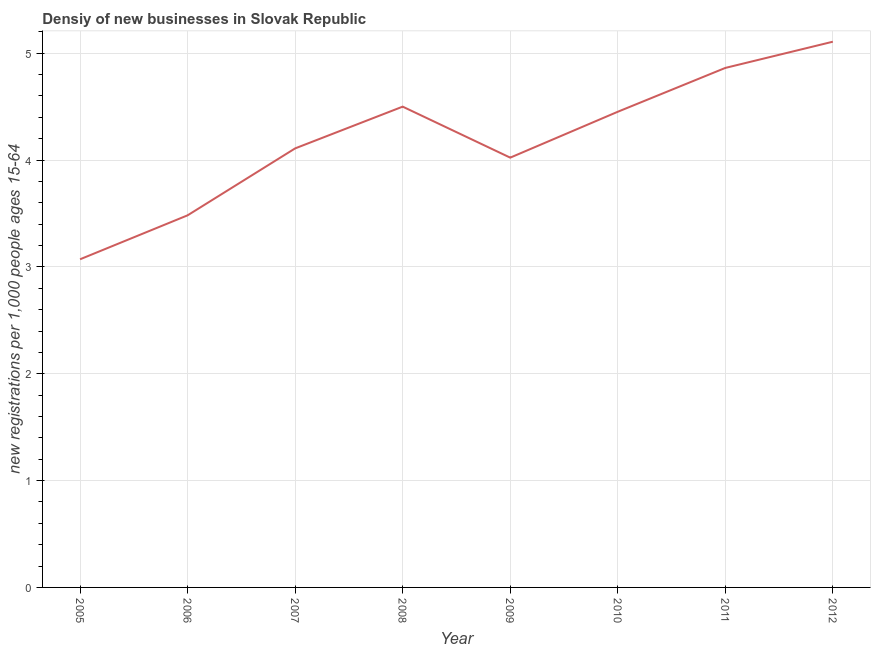What is the density of new business in 2007?
Your response must be concise. 4.11. Across all years, what is the maximum density of new business?
Provide a short and direct response. 5.11. Across all years, what is the minimum density of new business?
Provide a short and direct response. 3.07. In which year was the density of new business maximum?
Make the answer very short. 2012. What is the sum of the density of new business?
Offer a terse response. 33.61. What is the difference between the density of new business in 2009 and 2011?
Provide a short and direct response. -0.84. What is the average density of new business per year?
Make the answer very short. 4.2. What is the median density of new business?
Provide a succinct answer. 4.28. In how many years, is the density of new business greater than 1.8 ?
Offer a very short reply. 8. Do a majority of the years between 2009 and 2008 (inclusive) have density of new business greater than 4.8 ?
Provide a short and direct response. No. What is the ratio of the density of new business in 2005 to that in 2012?
Your response must be concise. 0.6. Is the density of new business in 2008 less than that in 2009?
Offer a terse response. No. Is the difference between the density of new business in 2009 and 2011 greater than the difference between any two years?
Your answer should be compact. No. What is the difference between the highest and the second highest density of new business?
Offer a very short reply. 0.25. Is the sum of the density of new business in 2010 and 2011 greater than the maximum density of new business across all years?
Make the answer very short. Yes. What is the difference between the highest and the lowest density of new business?
Ensure brevity in your answer.  2.04. Does the density of new business monotonically increase over the years?
Your answer should be compact. No. How many years are there in the graph?
Offer a very short reply. 8. What is the difference between two consecutive major ticks on the Y-axis?
Ensure brevity in your answer.  1. Are the values on the major ticks of Y-axis written in scientific E-notation?
Your answer should be very brief. No. What is the title of the graph?
Your answer should be compact. Densiy of new businesses in Slovak Republic. What is the label or title of the X-axis?
Give a very brief answer. Year. What is the label or title of the Y-axis?
Give a very brief answer. New registrations per 1,0 people ages 15-64. What is the new registrations per 1,000 people ages 15-64 of 2005?
Your response must be concise. 3.07. What is the new registrations per 1,000 people ages 15-64 in 2006?
Your answer should be very brief. 3.48. What is the new registrations per 1,000 people ages 15-64 of 2007?
Your answer should be very brief. 4.11. What is the new registrations per 1,000 people ages 15-64 in 2008?
Provide a short and direct response. 4.5. What is the new registrations per 1,000 people ages 15-64 of 2009?
Keep it short and to the point. 4.02. What is the new registrations per 1,000 people ages 15-64 of 2010?
Keep it short and to the point. 4.45. What is the new registrations per 1,000 people ages 15-64 in 2011?
Your answer should be compact. 4.86. What is the new registrations per 1,000 people ages 15-64 in 2012?
Your response must be concise. 5.11. What is the difference between the new registrations per 1,000 people ages 15-64 in 2005 and 2006?
Keep it short and to the point. -0.41. What is the difference between the new registrations per 1,000 people ages 15-64 in 2005 and 2007?
Offer a terse response. -1.04. What is the difference between the new registrations per 1,000 people ages 15-64 in 2005 and 2008?
Your response must be concise. -1.43. What is the difference between the new registrations per 1,000 people ages 15-64 in 2005 and 2009?
Provide a short and direct response. -0.95. What is the difference between the new registrations per 1,000 people ages 15-64 in 2005 and 2010?
Give a very brief answer. -1.38. What is the difference between the new registrations per 1,000 people ages 15-64 in 2005 and 2011?
Your answer should be compact. -1.79. What is the difference between the new registrations per 1,000 people ages 15-64 in 2005 and 2012?
Provide a short and direct response. -2.04. What is the difference between the new registrations per 1,000 people ages 15-64 in 2006 and 2007?
Offer a very short reply. -0.63. What is the difference between the new registrations per 1,000 people ages 15-64 in 2006 and 2008?
Provide a succinct answer. -1.02. What is the difference between the new registrations per 1,000 people ages 15-64 in 2006 and 2009?
Make the answer very short. -0.54. What is the difference between the new registrations per 1,000 people ages 15-64 in 2006 and 2010?
Provide a succinct answer. -0.97. What is the difference between the new registrations per 1,000 people ages 15-64 in 2006 and 2011?
Ensure brevity in your answer.  -1.38. What is the difference between the new registrations per 1,000 people ages 15-64 in 2006 and 2012?
Make the answer very short. -1.63. What is the difference between the new registrations per 1,000 people ages 15-64 in 2007 and 2008?
Your answer should be compact. -0.39. What is the difference between the new registrations per 1,000 people ages 15-64 in 2007 and 2009?
Your response must be concise. 0.09. What is the difference between the new registrations per 1,000 people ages 15-64 in 2007 and 2010?
Offer a terse response. -0.34. What is the difference between the new registrations per 1,000 people ages 15-64 in 2007 and 2011?
Make the answer very short. -0.75. What is the difference between the new registrations per 1,000 people ages 15-64 in 2007 and 2012?
Offer a terse response. -1. What is the difference between the new registrations per 1,000 people ages 15-64 in 2008 and 2009?
Give a very brief answer. 0.48. What is the difference between the new registrations per 1,000 people ages 15-64 in 2008 and 2010?
Provide a short and direct response. 0.05. What is the difference between the new registrations per 1,000 people ages 15-64 in 2008 and 2011?
Give a very brief answer. -0.36. What is the difference between the new registrations per 1,000 people ages 15-64 in 2008 and 2012?
Provide a short and direct response. -0.61. What is the difference between the new registrations per 1,000 people ages 15-64 in 2009 and 2010?
Make the answer very short. -0.43. What is the difference between the new registrations per 1,000 people ages 15-64 in 2009 and 2011?
Give a very brief answer. -0.84. What is the difference between the new registrations per 1,000 people ages 15-64 in 2009 and 2012?
Offer a very short reply. -1.09. What is the difference between the new registrations per 1,000 people ages 15-64 in 2010 and 2011?
Your answer should be compact. -0.41. What is the difference between the new registrations per 1,000 people ages 15-64 in 2010 and 2012?
Offer a terse response. -0.66. What is the difference between the new registrations per 1,000 people ages 15-64 in 2011 and 2012?
Give a very brief answer. -0.25. What is the ratio of the new registrations per 1,000 people ages 15-64 in 2005 to that in 2006?
Offer a terse response. 0.88. What is the ratio of the new registrations per 1,000 people ages 15-64 in 2005 to that in 2007?
Offer a terse response. 0.75. What is the ratio of the new registrations per 1,000 people ages 15-64 in 2005 to that in 2008?
Your response must be concise. 0.68. What is the ratio of the new registrations per 1,000 people ages 15-64 in 2005 to that in 2009?
Ensure brevity in your answer.  0.76. What is the ratio of the new registrations per 1,000 people ages 15-64 in 2005 to that in 2010?
Make the answer very short. 0.69. What is the ratio of the new registrations per 1,000 people ages 15-64 in 2005 to that in 2011?
Ensure brevity in your answer.  0.63. What is the ratio of the new registrations per 1,000 people ages 15-64 in 2005 to that in 2012?
Provide a short and direct response. 0.6. What is the ratio of the new registrations per 1,000 people ages 15-64 in 2006 to that in 2007?
Your answer should be very brief. 0.85. What is the ratio of the new registrations per 1,000 people ages 15-64 in 2006 to that in 2008?
Give a very brief answer. 0.77. What is the ratio of the new registrations per 1,000 people ages 15-64 in 2006 to that in 2009?
Provide a succinct answer. 0.87. What is the ratio of the new registrations per 1,000 people ages 15-64 in 2006 to that in 2010?
Offer a terse response. 0.78. What is the ratio of the new registrations per 1,000 people ages 15-64 in 2006 to that in 2011?
Offer a very short reply. 0.72. What is the ratio of the new registrations per 1,000 people ages 15-64 in 2006 to that in 2012?
Offer a very short reply. 0.68. What is the ratio of the new registrations per 1,000 people ages 15-64 in 2007 to that in 2008?
Your response must be concise. 0.91. What is the ratio of the new registrations per 1,000 people ages 15-64 in 2007 to that in 2009?
Make the answer very short. 1.02. What is the ratio of the new registrations per 1,000 people ages 15-64 in 2007 to that in 2010?
Keep it short and to the point. 0.92. What is the ratio of the new registrations per 1,000 people ages 15-64 in 2007 to that in 2011?
Provide a short and direct response. 0.84. What is the ratio of the new registrations per 1,000 people ages 15-64 in 2007 to that in 2012?
Keep it short and to the point. 0.8. What is the ratio of the new registrations per 1,000 people ages 15-64 in 2008 to that in 2009?
Provide a short and direct response. 1.12. What is the ratio of the new registrations per 1,000 people ages 15-64 in 2008 to that in 2011?
Your answer should be very brief. 0.93. What is the ratio of the new registrations per 1,000 people ages 15-64 in 2008 to that in 2012?
Your answer should be compact. 0.88. What is the ratio of the new registrations per 1,000 people ages 15-64 in 2009 to that in 2010?
Provide a succinct answer. 0.9. What is the ratio of the new registrations per 1,000 people ages 15-64 in 2009 to that in 2011?
Offer a very short reply. 0.83. What is the ratio of the new registrations per 1,000 people ages 15-64 in 2009 to that in 2012?
Provide a short and direct response. 0.79. What is the ratio of the new registrations per 1,000 people ages 15-64 in 2010 to that in 2011?
Your answer should be very brief. 0.92. What is the ratio of the new registrations per 1,000 people ages 15-64 in 2010 to that in 2012?
Your answer should be very brief. 0.87. What is the ratio of the new registrations per 1,000 people ages 15-64 in 2011 to that in 2012?
Offer a terse response. 0.95. 